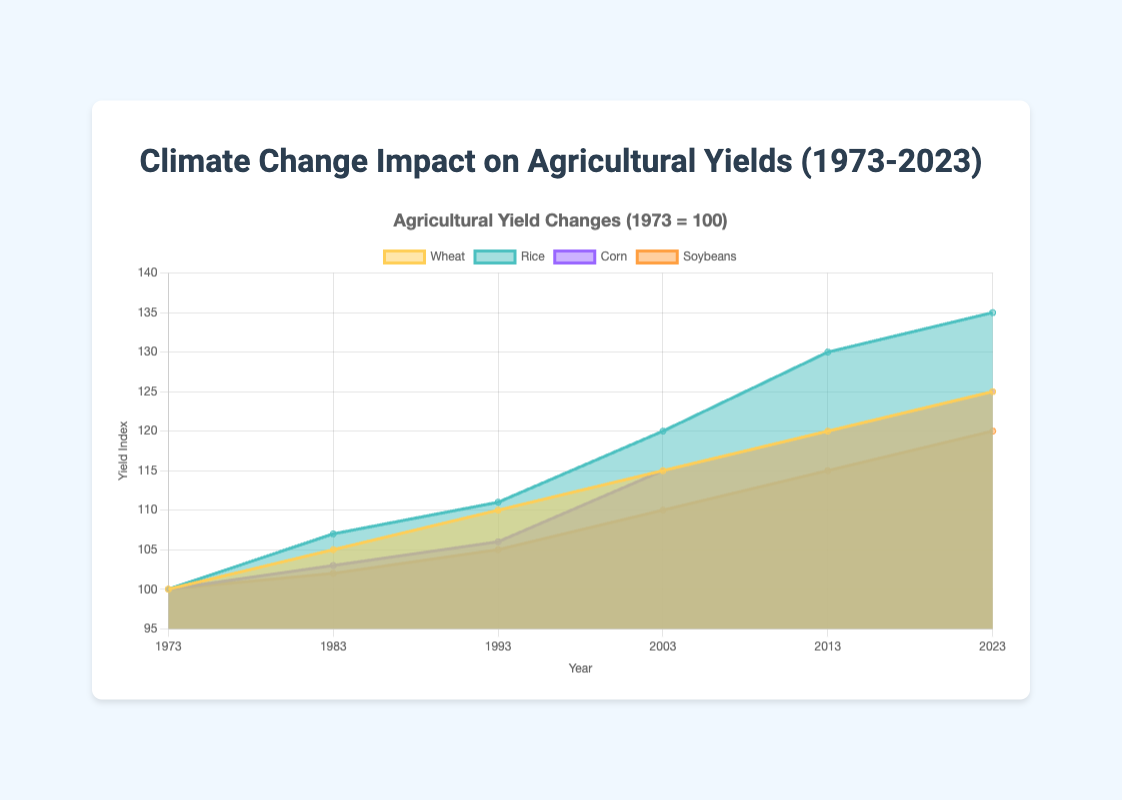What's the average yield index for wheat from 1973 to 2023? Add up the wheat yield indices (100 + 105 + 110 + 115 + 120 + 125 = 675) and divide by the number of data points (6). So, 675/6 = 112.5
Answer: 112.5 Which crop had the highest yield index in 2023? Refer to the 2023 data points for each crop: Wheat (125), Rice (135), Corn (125), and Soybeans (120). Rice has the highest yield index at 135.
Answer: Rice In which decade did rice experience the greatest increase in yield index? Compare the increase in rice yield index across each decade: 1973-1983 (7), 1983-1993 (4), 1993-2003 (9), 2003-2013 (10), and 2013-2023 (5). The biggest increase occurred from 2003 to 2013.
Answer: 2003-2013 How many total data points are represented in the chart? Count all the years listed on the x-axis for each crop: There are 6 years, and each crop has a data point for each year. Because there are 4 crops, the total is 6 * 4 = 24 data points.
Answer: 24 By how much did the corn yield index increase from 1983 to 2023? Subtract the corn yield index in 1983 (103) from the index in 2023 (125). So, 125 - 103 = 22.
Answer: 22 What is the title of the figure? The title is written at the top of the figure and is "Climate Change Impact on Agricultural Yields (1973-2023)"
Answer: Climate Change Impact on Agricultural Yields (1973-2023) Which crop had the least increase in yield index over 50 years? Determine the increase for each crop from 1973 to 2023: Wheat (25), Rice (35), Corn (25), Soybeans (20). Soybeans had the smallest increase.
Answer: Soybeans Which crop showed the least consistent growth in yield index between each decade? Examine the change in yield index for each crop from decade to decade. The crop with the most variation in decade-to-decade changes indicates the least consistent growth. Rice had increments of 7, 4, 9, 10, and 5, indicating less consistent growth compared to others.
Answer: Rice What is the color used to represent soybeans in the chart? The color representing soybeans is indicated in the chart legend, which is a shade of orange.
Answer: Orange Which crop had a higher yield index in 2003 compared to 1993 but a lower yield index in 2013 compared to 2023? Check each crop's yield index for those years: Wheat (110 -> 115 -> 120 ->125), Rice (111 -> 120 -> 130 -> 135), Corn (106 -> 115 -> 120 -> 125), Soybeans (105 -> 110 -> 115 -> 120). All crops had greater yield indexes in 2013 compared to 2023. This question is unanswerable with current data presentation.
Answer: This question is unanswerable with current data presentation 